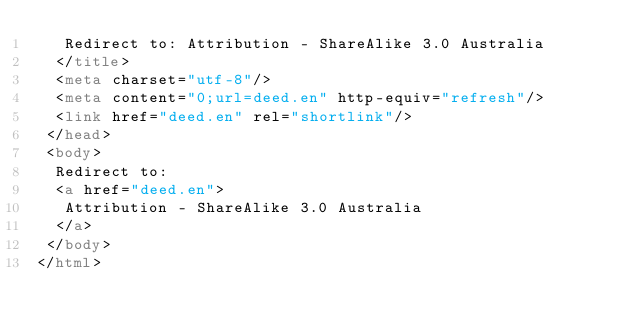<code> <loc_0><loc_0><loc_500><loc_500><_HTML_>   Redirect to: Attribution - ShareAlike 3.0 Australia
  </title>
  <meta charset="utf-8"/>
  <meta content="0;url=deed.en" http-equiv="refresh"/>
  <link href="deed.en" rel="shortlink"/>
 </head>
 <body>
  Redirect to:
  <a href="deed.en">
   Attribution - ShareAlike 3.0 Australia
  </a>
 </body>
</html>
</code> 